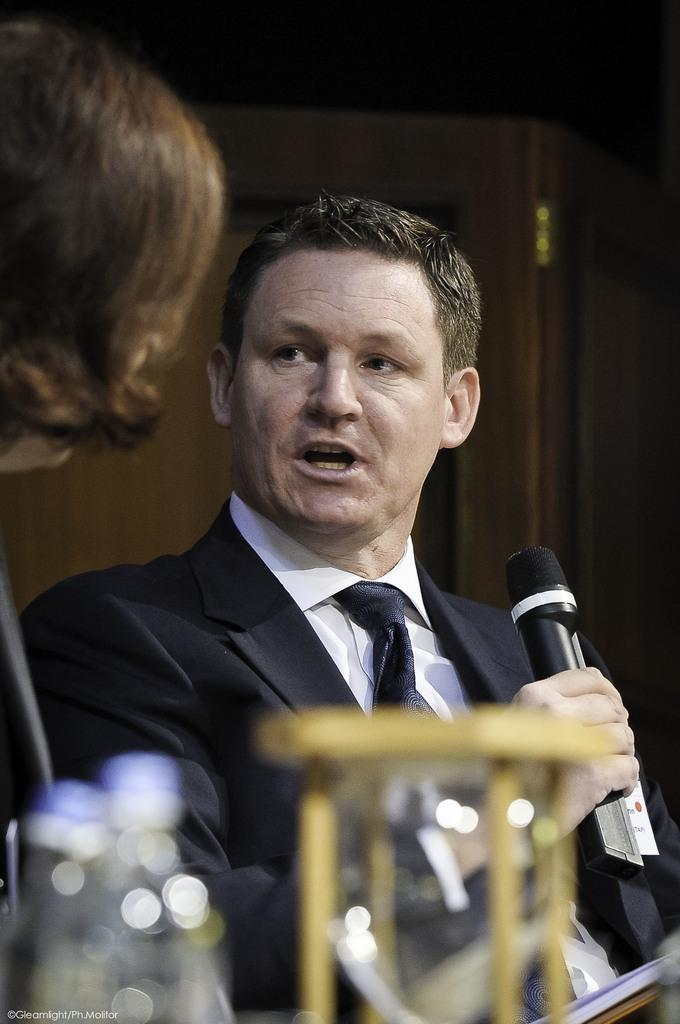How many people are present in the image? There are two people, a man and a woman, present in the image. What is the man wearing in the image? The man is wearing a black color blazer in the image. What is the man holding in his hand? The man is holding a mic in his hand in the image. Can you see a toad sitting on the man's shoulder in the image? No, there is no toad present in the image. 